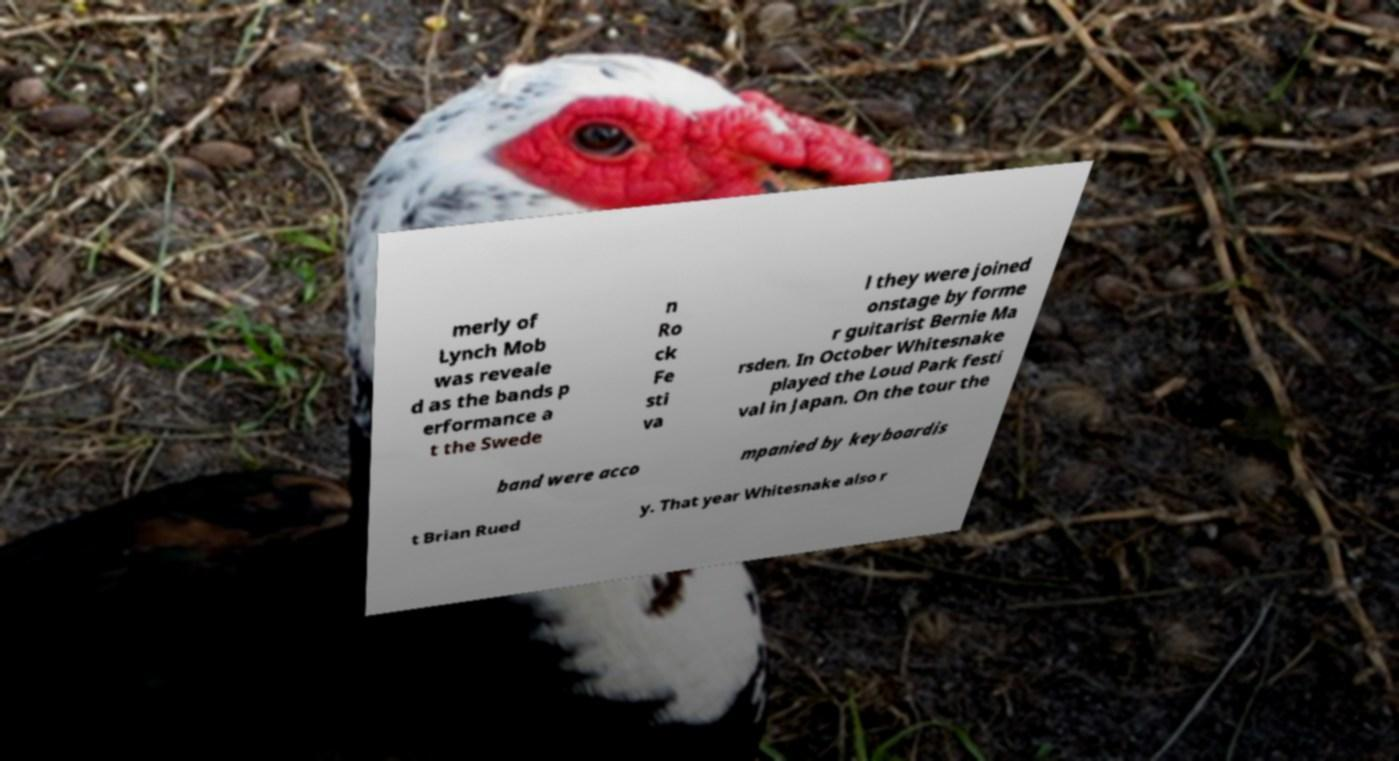Could you extract and type out the text from this image? merly of Lynch Mob was reveale d as the bands p erformance a t the Swede n Ro ck Fe sti va l they were joined onstage by forme r guitarist Bernie Ma rsden. In October Whitesnake played the Loud Park festi val in Japan. On the tour the band were acco mpanied by keyboardis t Brian Rued y. That year Whitesnake also r 